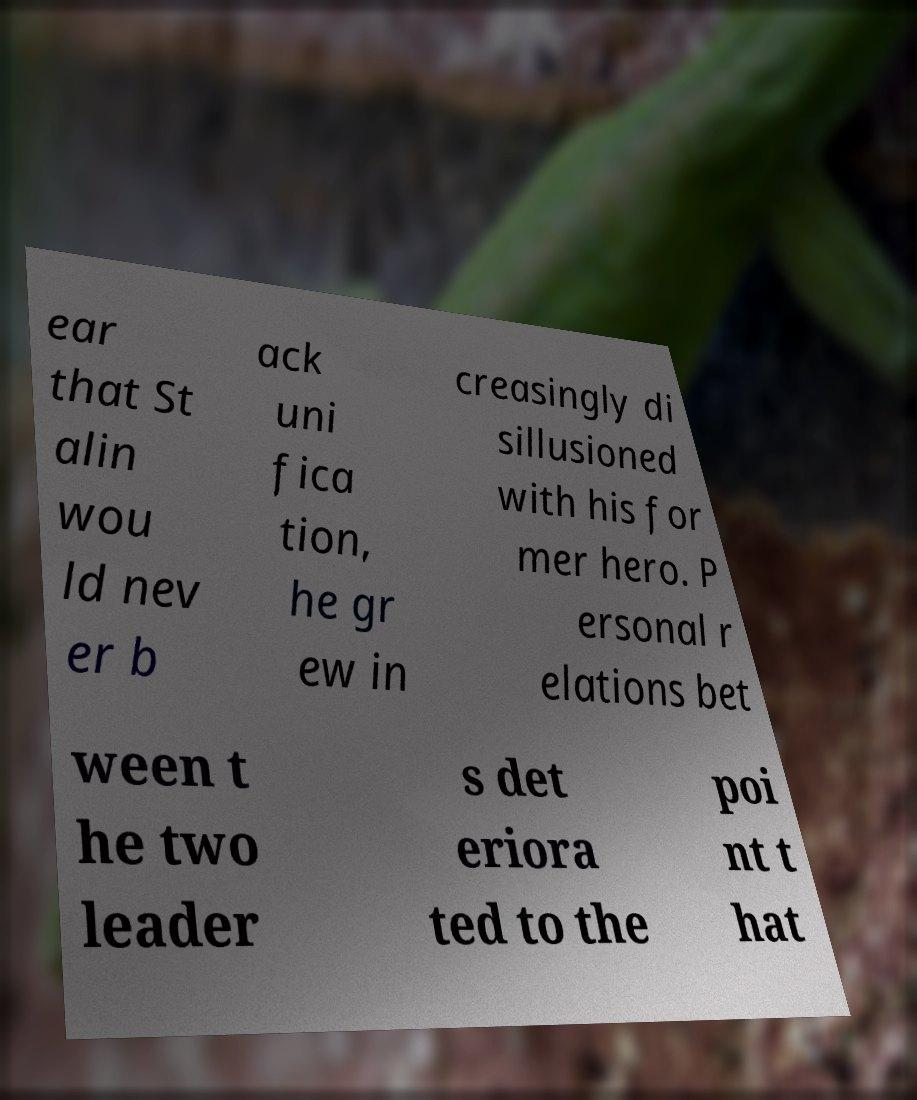I need the written content from this picture converted into text. Can you do that? ear that St alin wou ld nev er b ack uni fica tion, he gr ew in creasingly di sillusioned with his for mer hero. P ersonal r elations bet ween t he two leader s det eriora ted to the poi nt t hat 